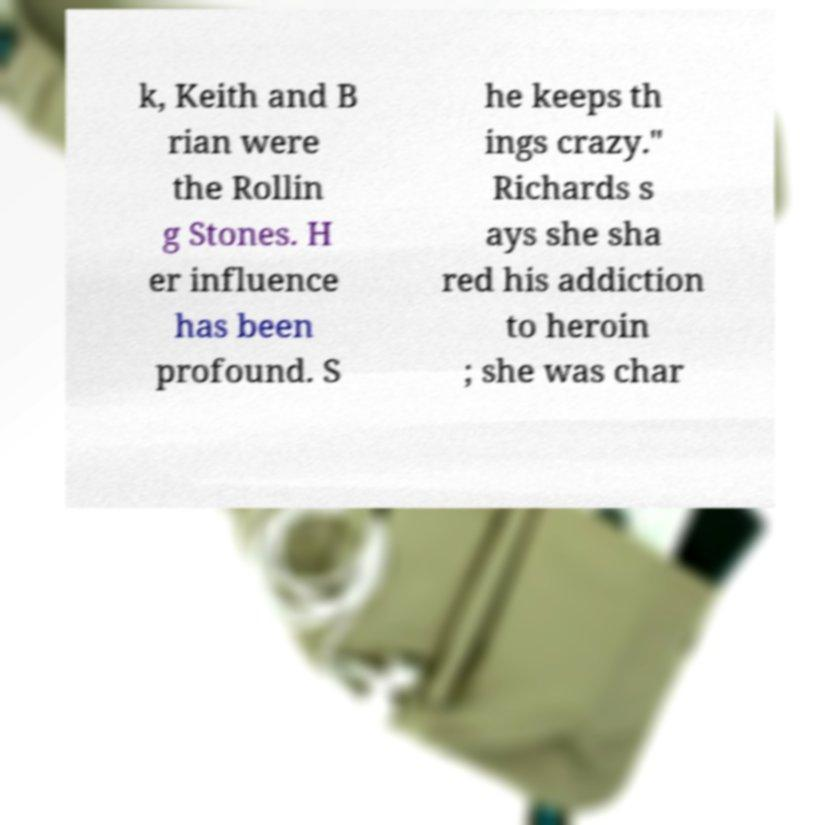Could you assist in decoding the text presented in this image and type it out clearly? k, Keith and B rian were the Rollin g Stones. H er influence has been profound. S he keeps th ings crazy." Richards s ays she sha red his addiction to heroin ; she was char 